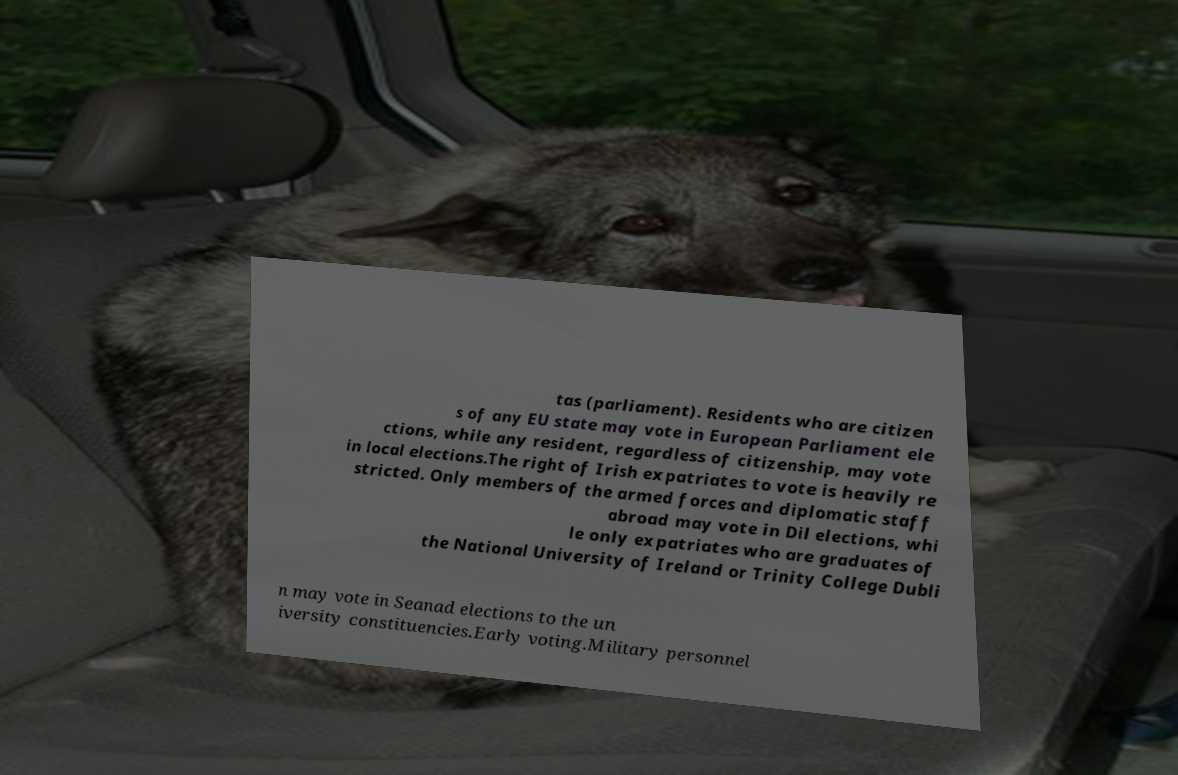Could you extract and type out the text from this image? tas (parliament). Residents who are citizen s of any EU state may vote in European Parliament ele ctions, while any resident, regardless of citizenship, may vote in local elections.The right of Irish expatriates to vote is heavily re stricted. Only members of the armed forces and diplomatic staff abroad may vote in Dil elections, whi le only expatriates who are graduates of the National University of Ireland or Trinity College Dubli n may vote in Seanad elections to the un iversity constituencies.Early voting.Military personnel 